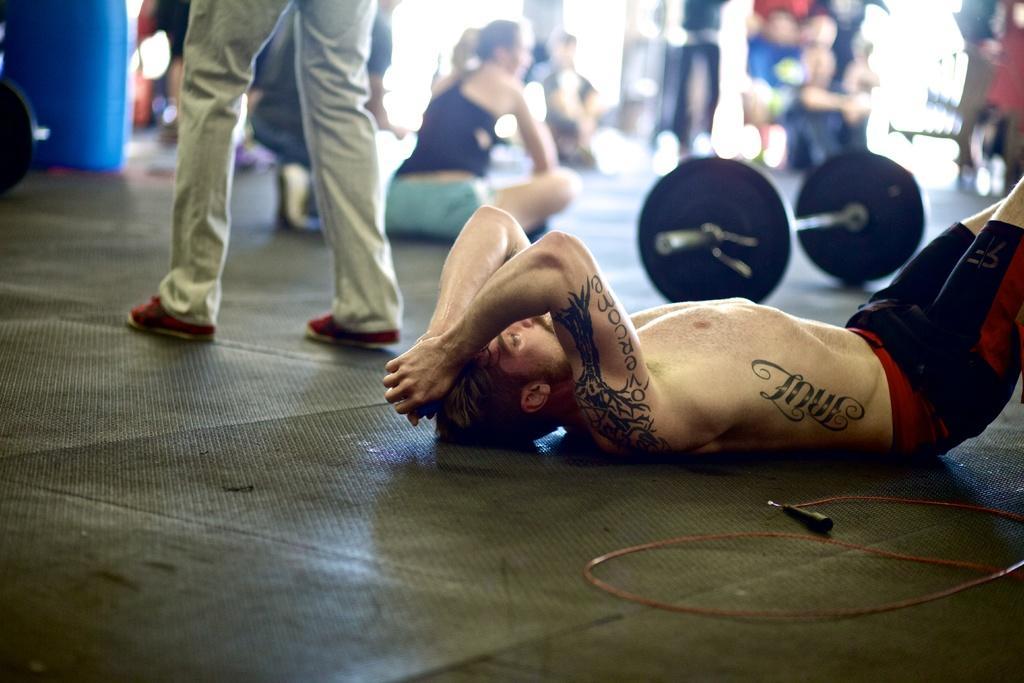Can you describe this image briefly? In this image we can see a person lying on the ground. In the background we can see persons sitting and standing on the floor. In the background we can see gym equipment. 